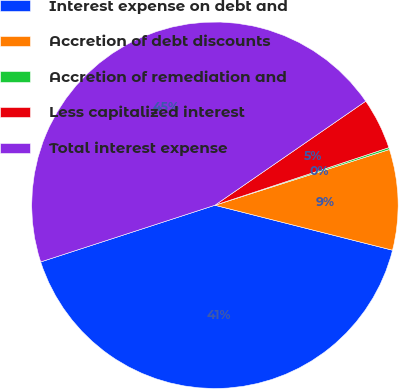Convert chart. <chart><loc_0><loc_0><loc_500><loc_500><pie_chart><fcel>Interest expense on debt and<fcel>Accretion of debt discounts<fcel>Accretion of remediation and<fcel>Less capitalized interest<fcel>Total interest expense<nl><fcel>41.05%<fcel>8.87%<fcel>0.17%<fcel>4.52%<fcel>45.4%<nl></chart> 